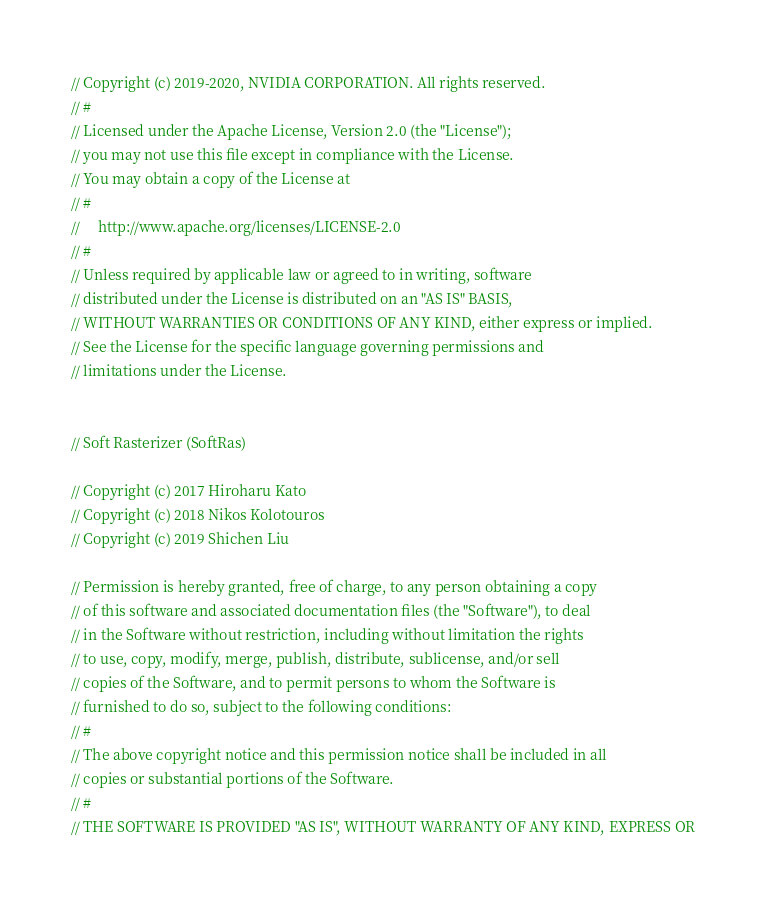Convert code to text. <code><loc_0><loc_0><loc_500><loc_500><_Cuda_>// Copyright (c) 2019-2020, NVIDIA CORPORATION. All rights reserved.
// #
// Licensed under the Apache License, Version 2.0 (the "License");
// you may not use this file except in compliance with the License.
// You may obtain a copy of the License at
// #
//     http://www.apache.org/licenses/LICENSE-2.0
// #
// Unless required by applicable law or agreed to in writing, software
// distributed under the License is distributed on an "AS IS" BASIS,
// WITHOUT WARRANTIES OR CONDITIONS OF ANY KIND, either express or implied.
// See the License for the specific language governing permissions and
// limitations under the License.


// Soft Rasterizer (SoftRas)

// Copyright (c) 2017 Hiroharu Kato
// Copyright (c) 2018 Nikos Kolotouros
// Copyright (c) 2019 Shichen Liu

// Permission is hereby granted, free of charge, to any person obtaining a copy
// of this software and associated documentation files (the "Software"), to deal
// in the Software without restriction, including without limitation the rights
// to use, copy, modify, merge, publish, distribute, sublicense, and/or sell
// copies of the Software, and to permit persons to whom the Software is
// furnished to do so, subject to the following conditions:
// #
// The above copyright notice and this permission notice shall be included in all
// copies or substantial portions of the Software.
// #
// THE SOFTWARE IS PROVIDED "AS IS", WITHOUT WARRANTY OF ANY KIND, EXPRESS OR</code> 